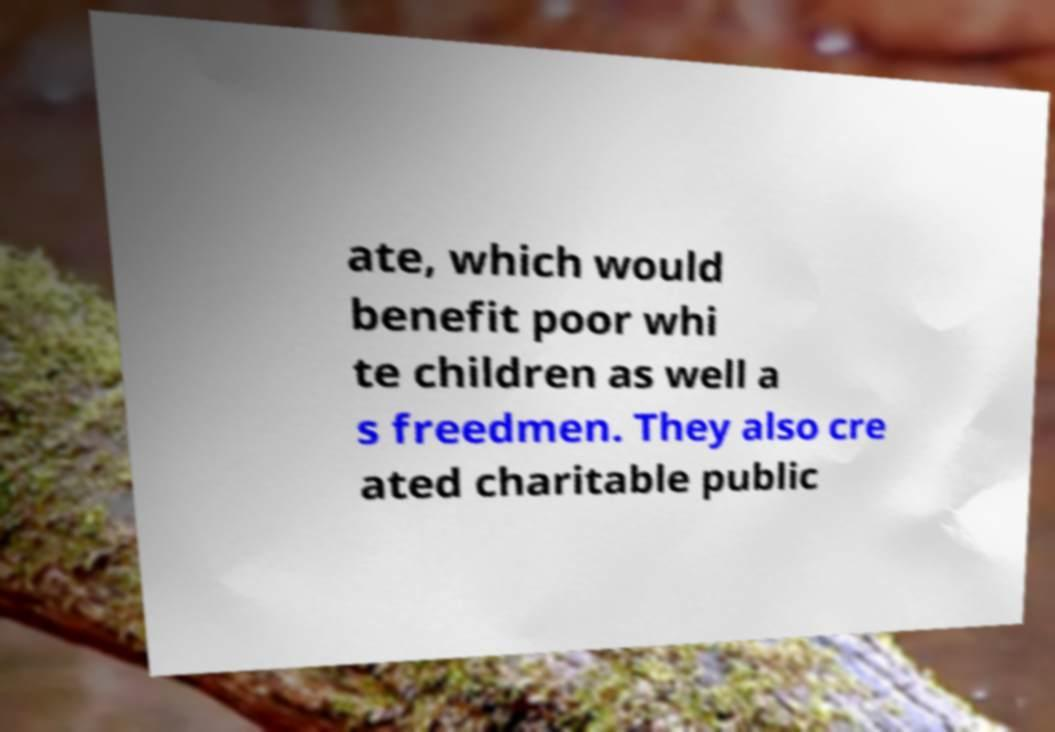Please identify and transcribe the text found in this image. ate, which would benefit poor whi te children as well a s freedmen. They also cre ated charitable public 